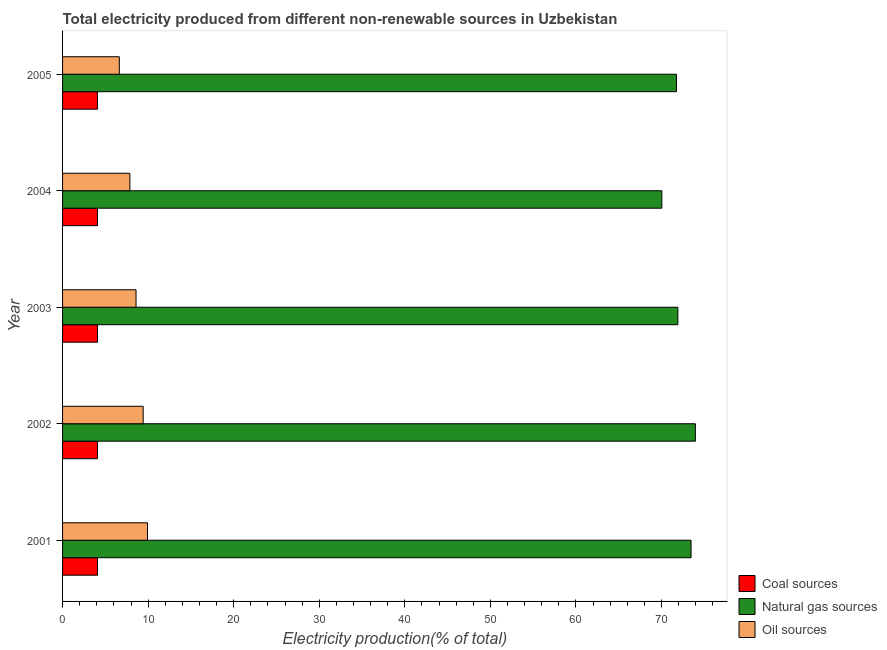How many different coloured bars are there?
Give a very brief answer. 3. Are the number of bars on each tick of the Y-axis equal?
Offer a terse response. Yes. How many bars are there on the 3rd tick from the top?
Give a very brief answer. 3. What is the label of the 1st group of bars from the top?
Your answer should be very brief. 2005. What is the percentage of electricity produced by coal in 2003?
Offer a terse response. 4.09. Across all years, what is the maximum percentage of electricity produced by oil sources?
Keep it short and to the point. 9.92. Across all years, what is the minimum percentage of electricity produced by natural gas?
Your answer should be very brief. 70.03. In which year was the percentage of electricity produced by oil sources minimum?
Give a very brief answer. 2005. What is the total percentage of electricity produced by oil sources in the graph?
Keep it short and to the point. 42.43. What is the difference between the percentage of electricity produced by oil sources in 2002 and that in 2005?
Your response must be concise. 2.79. What is the difference between the percentage of electricity produced by oil sources in 2001 and the percentage of electricity produced by natural gas in 2003?
Provide a succinct answer. -61.98. What is the average percentage of electricity produced by oil sources per year?
Keep it short and to the point. 8.48. In the year 2002, what is the difference between the percentage of electricity produced by coal and percentage of electricity produced by oil sources?
Offer a terse response. -5.34. In how many years, is the percentage of electricity produced by oil sources greater than 26 %?
Keep it short and to the point. 0. Is the percentage of electricity produced by oil sources in 2002 less than that in 2003?
Provide a succinct answer. No. What is the difference between the highest and the second highest percentage of electricity produced by coal?
Your answer should be compact. 0. What is the difference between the highest and the lowest percentage of electricity produced by oil sources?
Offer a terse response. 3.29. What does the 2nd bar from the top in 2004 represents?
Offer a terse response. Natural gas sources. What does the 2nd bar from the bottom in 2005 represents?
Your answer should be compact. Natural gas sources. Is it the case that in every year, the sum of the percentage of electricity produced by coal and percentage of electricity produced by natural gas is greater than the percentage of electricity produced by oil sources?
Ensure brevity in your answer.  Yes. Are all the bars in the graph horizontal?
Provide a short and direct response. Yes. Does the graph contain any zero values?
Give a very brief answer. No. Does the graph contain grids?
Keep it short and to the point. No. What is the title of the graph?
Make the answer very short. Total electricity produced from different non-renewable sources in Uzbekistan. What is the label or title of the Y-axis?
Provide a short and direct response. Year. What is the Electricity production(% of total) of Coal sources in 2001?
Your response must be concise. 4.08. What is the Electricity production(% of total) in Natural gas sources in 2001?
Your answer should be compact. 73.45. What is the Electricity production(% of total) in Oil sources in 2001?
Ensure brevity in your answer.  9.92. What is the Electricity production(% of total) of Coal sources in 2002?
Your answer should be very brief. 4.08. What is the Electricity production(% of total) in Natural gas sources in 2002?
Ensure brevity in your answer.  73.95. What is the Electricity production(% of total) of Oil sources in 2002?
Your answer should be very brief. 9.42. What is the Electricity production(% of total) in Coal sources in 2003?
Make the answer very short. 4.09. What is the Electricity production(% of total) in Natural gas sources in 2003?
Your response must be concise. 71.9. What is the Electricity production(% of total) in Oil sources in 2003?
Your answer should be compact. 8.59. What is the Electricity production(% of total) in Coal sources in 2004?
Your response must be concise. 4.09. What is the Electricity production(% of total) in Natural gas sources in 2004?
Make the answer very short. 70.03. What is the Electricity production(% of total) in Oil sources in 2004?
Your answer should be very brief. 7.86. What is the Electricity production(% of total) of Coal sources in 2005?
Offer a terse response. 4.08. What is the Electricity production(% of total) of Natural gas sources in 2005?
Make the answer very short. 71.74. What is the Electricity production(% of total) of Oil sources in 2005?
Make the answer very short. 6.63. Across all years, what is the maximum Electricity production(% of total) of Coal sources?
Your response must be concise. 4.09. Across all years, what is the maximum Electricity production(% of total) of Natural gas sources?
Give a very brief answer. 73.95. Across all years, what is the maximum Electricity production(% of total) in Oil sources?
Your answer should be very brief. 9.92. Across all years, what is the minimum Electricity production(% of total) in Coal sources?
Offer a very short reply. 4.08. Across all years, what is the minimum Electricity production(% of total) of Natural gas sources?
Provide a succinct answer. 70.03. Across all years, what is the minimum Electricity production(% of total) in Oil sources?
Your answer should be very brief. 6.63. What is the total Electricity production(% of total) of Coal sources in the graph?
Keep it short and to the point. 20.42. What is the total Electricity production(% of total) in Natural gas sources in the graph?
Offer a terse response. 361.08. What is the total Electricity production(% of total) of Oil sources in the graph?
Your answer should be very brief. 42.43. What is the difference between the Electricity production(% of total) of Coal sources in 2001 and that in 2002?
Offer a very short reply. -0. What is the difference between the Electricity production(% of total) of Natural gas sources in 2001 and that in 2002?
Your answer should be very brief. -0.5. What is the difference between the Electricity production(% of total) in Oil sources in 2001 and that in 2002?
Offer a very short reply. 0.5. What is the difference between the Electricity production(% of total) of Coal sources in 2001 and that in 2003?
Offer a very short reply. -0. What is the difference between the Electricity production(% of total) in Natural gas sources in 2001 and that in 2003?
Offer a very short reply. 1.54. What is the difference between the Electricity production(% of total) in Oil sources in 2001 and that in 2003?
Keep it short and to the point. 1.34. What is the difference between the Electricity production(% of total) in Coal sources in 2001 and that in 2004?
Provide a short and direct response. -0. What is the difference between the Electricity production(% of total) of Natural gas sources in 2001 and that in 2004?
Your answer should be compact. 3.42. What is the difference between the Electricity production(% of total) in Oil sources in 2001 and that in 2004?
Your response must be concise. 2.06. What is the difference between the Electricity production(% of total) of Coal sources in 2001 and that in 2005?
Provide a succinct answer. 0. What is the difference between the Electricity production(% of total) of Natural gas sources in 2001 and that in 2005?
Your response must be concise. 1.7. What is the difference between the Electricity production(% of total) of Oil sources in 2001 and that in 2005?
Keep it short and to the point. 3.29. What is the difference between the Electricity production(% of total) of Coal sources in 2002 and that in 2003?
Make the answer very short. -0. What is the difference between the Electricity production(% of total) of Natural gas sources in 2002 and that in 2003?
Ensure brevity in your answer.  2.05. What is the difference between the Electricity production(% of total) of Oil sources in 2002 and that in 2003?
Offer a terse response. 0.83. What is the difference between the Electricity production(% of total) in Coal sources in 2002 and that in 2004?
Make the answer very short. -0. What is the difference between the Electricity production(% of total) of Natural gas sources in 2002 and that in 2004?
Ensure brevity in your answer.  3.92. What is the difference between the Electricity production(% of total) of Oil sources in 2002 and that in 2004?
Offer a very short reply. 1.56. What is the difference between the Electricity production(% of total) in Natural gas sources in 2002 and that in 2005?
Your response must be concise. 2.21. What is the difference between the Electricity production(% of total) in Oil sources in 2002 and that in 2005?
Your response must be concise. 2.79. What is the difference between the Electricity production(% of total) in Coal sources in 2003 and that in 2004?
Offer a terse response. -0. What is the difference between the Electricity production(% of total) in Natural gas sources in 2003 and that in 2004?
Give a very brief answer. 1.87. What is the difference between the Electricity production(% of total) in Oil sources in 2003 and that in 2004?
Your response must be concise. 0.72. What is the difference between the Electricity production(% of total) of Coal sources in 2003 and that in 2005?
Offer a very short reply. 0. What is the difference between the Electricity production(% of total) of Natural gas sources in 2003 and that in 2005?
Keep it short and to the point. 0.16. What is the difference between the Electricity production(% of total) of Oil sources in 2003 and that in 2005?
Provide a succinct answer. 1.95. What is the difference between the Electricity production(% of total) of Coal sources in 2004 and that in 2005?
Your answer should be very brief. 0. What is the difference between the Electricity production(% of total) of Natural gas sources in 2004 and that in 2005?
Make the answer very short. -1.71. What is the difference between the Electricity production(% of total) in Oil sources in 2004 and that in 2005?
Your answer should be very brief. 1.23. What is the difference between the Electricity production(% of total) in Coal sources in 2001 and the Electricity production(% of total) in Natural gas sources in 2002?
Provide a short and direct response. -69.87. What is the difference between the Electricity production(% of total) in Coal sources in 2001 and the Electricity production(% of total) in Oil sources in 2002?
Keep it short and to the point. -5.34. What is the difference between the Electricity production(% of total) of Natural gas sources in 2001 and the Electricity production(% of total) of Oil sources in 2002?
Provide a succinct answer. 64.03. What is the difference between the Electricity production(% of total) of Coal sources in 2001 and the Electricity production(% of total) of Natural gas sources in 2003?
Your response must be concise. -67.82. What is the difference between the Electricity production(% of total) in Coal sources in 2001 and the Electricity production(% of total) in Oil sources in 2003?
Make the answer very short. -4.5. What is the difference between the Electricity production(% of total) of Natural gas sources in 2001 and the Electricity production(% of total) of Oil sources in 2003?
Provide a short and direct response. 64.86. What is the difference between the Electricity production(% of total) of Coal sources in 2001 and the Electricity production(% of total) of Natural gas sources in 2004?
Provide a short and direct response. -65.95. What is the difference between the Electricity production(% of total) of Coal sources in 2001 and the Electricity production(% of total) of Oil sources in 2004?
Give a very brief answer. -3.78. What is the difference between the Electricity production(% of total) of Natural gas sources in 2001 and the Electricity production(% of total) of Oil sources in 2004?
Your response must be concise. 65.58. What is the difference between the Electricity production(% of total) in Coal sources in 2001 and the Electricity production(% of total) in Natural gas sources in 2005?
Your answer should be very brief. -67.66. What is the difference between the Electricity production(% of total) of Coal sources in 2001 and the Electricity production(% of total) of Oil sources in 2005?
Provide a short and direct response. -2.55. What is the difference between the Electricity production(% of total) in Natural gas sources in 2001 and the Electricity production(% of total) in Oil sources in 2005?
Give a very brief answer. 66.81. What is the difference between the Electricity production(% of total) in Coal sources in 2002 and the Electricity production(% of total) in Natural gas sources in 2003?
Give a very brief answer. -67.82. What is the difference between the Electricity production(% of total) in Coal sources in 2002 and the Electricity production(% of total) in Oil sources in 2003?
Give a very brief answer. -4.5. What is the difference between the Electricity production(% of total) of Natural gas sources in 2002 and the Electricity production(% of total) of Oil sources in 2003?
Your response must be concise. 65.37. What is the difference between the Electricity production(% of total) in Coal sources in 2002 and the Electricity production(% of total) in Natural gas sources in 2004?
Provide a succinct answer. -65.95. What is the difference between the Electricity production(% of total) in Coal sources in 2002 and the Electricity production(% of total) in Oil sources in 2004?
Keep it short and to the point. -3.78. What is the difference between the Electricity production(% of total) of Natural gas sources in 2002 and the Electricity production(% of total) of Oil sources in 2004?
Provide a short and direct response. 66.09. What is the difference between the Electricity production(% of total) of Coal sources in 2002 and the Electricity production(% of total) of Natural gas sources in 2005?
Offer a terse response. -67.66. What is the difference between the Electricity production(% of total) in Coal sources in 2002 and the Electricity production(% of total) in Oil sources in 2005?
Your response must be concise. -2.55. What is the difference between the Electricity production(% of total) of Natural gas sources in 2002 and the Electricity production(% of total) of Oil sources in 2005?
Your answer should be compact. 67.32. What is the difference between the Electricity production(% of total) in Coal sources in 2003 and the Electricity production(% of total) in Natural gas sources in 2004?
Provide a succinct answer. -65.94. What is the difference between the Electricity production(% of total) of Coal sources in 2003 and the Electricity production(% of total) of Oil sources in 2004?
Offer a very short reply. -3.78. What is the difference between the Electricity production(% of total) of Natural gas sources in 2003 and the Electricity production(% of total) of Oil sources in 2004?
Offer a very short reply. 64.04. What is the difference between the Electricity production(% of total) of Coal sources in 2003 and the Electricity production(% of total) of Natural gas sources in 2005?
Ensure brevity in your answer.  -67.66. What is the difference between the Electricity production(% of total) in Coal sources in 2003 and the Electricity production(% of total) in Oil sources in 2005?
Provide a succinct answer. -2.55. What is the difference between the Electricity production(% of total) of Natural gas sources in 2003 and the Electricity production(% of total) of Oil sources in 2005?
Provide a succinct answer. 65.27. What is the difference between the Electricity production(% of total) in Coal sources in 2004 and the Electricity production(% of total) in Natural gas sources in 2005?
Provide a succinct answer. -67.66. What is the difference between the Electricity production(% of total) of Coal sources in 2004 and the Electricity production(% of total) of Oil sources in 2005?
Your response must be concise. -2.55. What is the difference between the Electricity production(% of total) of Natural gas sources in 2004 and the Electricity production(% of total) of Oil sources in 2005?
Make the answer very short. 63.4. What is the average Electricity production(% of total) in Coal sources per year?
Your response must be concise. 4.08. What is the average Electricity production(% of total) in Natural gas sources per year?
Keep it short and to the point. 72.22. What is the average Electricity production(% of total) of Oil sources per year?
Give a very brief answer. 8.49. In the year 2001, what is the difference between the Electricity production(% of total) of Coal sources and Electricity production(% of total) of Natural gas sources?
Offer a very short reply. -69.36. In the year 2001, what is the difference between the Electricity production(% of total) of Coal sources and Electricity production(% of total) of Oil sources?
Provide a succinct answer. -5.84. In the year 2001, what is the difference between the Electricity production(% of total) in Natural gas sources and Electricity production(% of total) in Oil sources?
Make the answer very short. 63.52. In the year 2002, what is the difference between the Electricity production(% of total) of Coal sources and Electricity production(% of total) of Natural gas sources?
Your response must be concise. -69.87. In the year 2002, what is the difference between the Electricity production(% of total) of Coal sources and Electricity production(% of total) of Oil sources?
Provide a short and direct response. -5.34. In the year 2002, what is the difference between the Electricity production(% of total) in Natural gas sources and Electricity production(% of total) in Oil sources?
Make the answer very short. 64.53. In the year 2003, what is the difference between the Electricity production(% of total) of Coal sources and Electricity production(% of total) of Natural gas sources?
Provide a succinct answer. -67.82. In the year 2003, what is the difference between the Electricity production(% of total) in Coal sources and Electricity production(% of total) in Oil sources?
Make the answer very short. -4.5. In the year 2003, what is the difference between the Electricity production(% of total) in Natural gas sources and Electricity production(% of total) in Oil sources?
Your answer should be compact. 63.32. In the year 2004, what is the difference between the Electricity production(% of total) of Coal sources and Electricity production(% of total) of Natural gas sources?
Your answer should be very brief. -65.94. In the year 2004, what is the difference between the Electricity production(% of total) in Coal sources and Electricity production(% of total) in Oil sources?
Your response must be concise. -3.78. In the year 2004, what is the difference between the Electricity production(% of total) of Natural gas sources and Electricity production(% of total) of Oil sources?
Provide a short and direct response. 62.17. In the year 2005, what is the difference between the Electricity production(% of total) of Coal sources and Electricity production(% of total) of Natural gas sources?
Give a very brief answer. -67.66. In the year 2005, what is the difference between the Electricity production(% of total) of Coal sources and Electricity production(% of total) of Oil sources?
Your answer should be very brief. -2.55. In the year 2005, what is the difference between the Electricity production(% of total) in Natural gas sources and Electricity production(% of total) in Oil sources?
Your answer should be compact. 65.11. What is the ratio of the Electricity production(% of total) in Coal sources in 2001 to that in 2002?
Keep it short and to the point. 1. What is the ratio of the Electricity production(% of total) in Oil sources in 2001 to that in 2002?
Offer a terse response. 1.05. What is the ratio of the Electricity production(% of total) in Natural gas sources in 2001 to that in 2003?
Make the answer very short. 1.02. What is the ratio of the Electricity production(% of total) of Oil sources in 2001 to that in 2003?
Provide a short and direct response. 1.16. What is the ratio of the Electricity production(% of total) of Natural gas sources in 2001 to that in 2004?
Your answer should be compact. 1.05. What is the ratio of the Electricity production(% of total) in Oil sources in 2001 to that in 2004?
Provide a short and direct response. 1.26. What is the ratio of the Electricity production(% of total) in Natural gas sources in 2001 to that in 2005?
Give a very brief answer. 1.02. What is the ratio of the Electricity production(% of total) of Oil sources in 2001 to that in 2005?
Offer a very short reply. 1.5. What is the ratio of the Electricity production(% of total) in Coal sources in 2002 to that in 2003?
Provide a succinct answer. 1. What is the ratio of the Electricity production(% of total) in Natural gas sources in 2002 to that in 2003?
Ensure brevity in your answer.  1.03. What is the ratio of the Electricity production(% of total) in Oil sources in 2002 to that in 2003?
Provide a short and direct response. 1.1. What is the ratio of the Electricity production(% of total) of Coal sources in 2002 to that in 2004?
Provide a succinct answer. 1. What is the ratio of the Electricity production(% of total) in Natural gas sources in 2002 to that in 2004?
Give a very brief answer. 1.06. What is the ratio of the Electricity production(% of total) in Oil sources in 2002 to that in 2004?
Your answer should be very brief. 1.2. What is the ratio of the Electricity production(% of total) of Coal sources in 2002 to that in 2005?
Provide a short and direct response. 1. What is the ratio of the Electricity production(% of total) in Natural gas sources in 2002 to that in 2005?
Make the answer very short. 1.03. What is the ratio of the Electricity production(% of total) of Oil sources in 2002 to that in 2005?
Give a very brief answer. 1.42. What is the ratio of the Electricity production(% of total) of Natural gas sources in 2003 to that in 2004?
Keep it short and to the point. 1.03. What is the ratio of the Electricity production(% of total) of Oil sources in 2003 to that in 2004?
Your answer should be very brief. 1.09. What is the ratio of the Electricity production(% of total) of Coal sources in 2003 to that in 2005?
Your answer should be very brief. 1. What is the ratio of the Electricity production(% of total) in Oil sources in 2003 to that in 2005?
Your answer should be compact. 1.29. What is the ratio of the Electricity production(% of total) in Coal sources in 2004 to that in 2005?
Give a very brief answer. 1. What is the ratio of the Electricity production(% of total) in Natural gas sources in 2004 to that in 2005?
Your answer should be compact. 0.98. What is the ratio of the Electricity production(% of total) in Oil sources in 2004 to that in 2005?
Make the answer very short. 1.19. What is the difference between the highest and the second highest Electricity production(% of total) in Natural gas sources?
Your response must be concise. 0.5. What is the difference between the highest and the second highest Electricity production(% of total) in Oil sources?
Provide a short and direct response. 0.5. What is the difference between the highest and the lowest Electricity production(% of total) in Coal sources?
Provide a short and direct response. 0. What is the difference between the highest and the lowest Electricity production(% of total) in Natural gas sources?
Offer a terse response. 3.92. What is the difference between the highest and the lowest Electricity production(% of total) in Oil sources?
Your answer should be very brief. 3.29. 